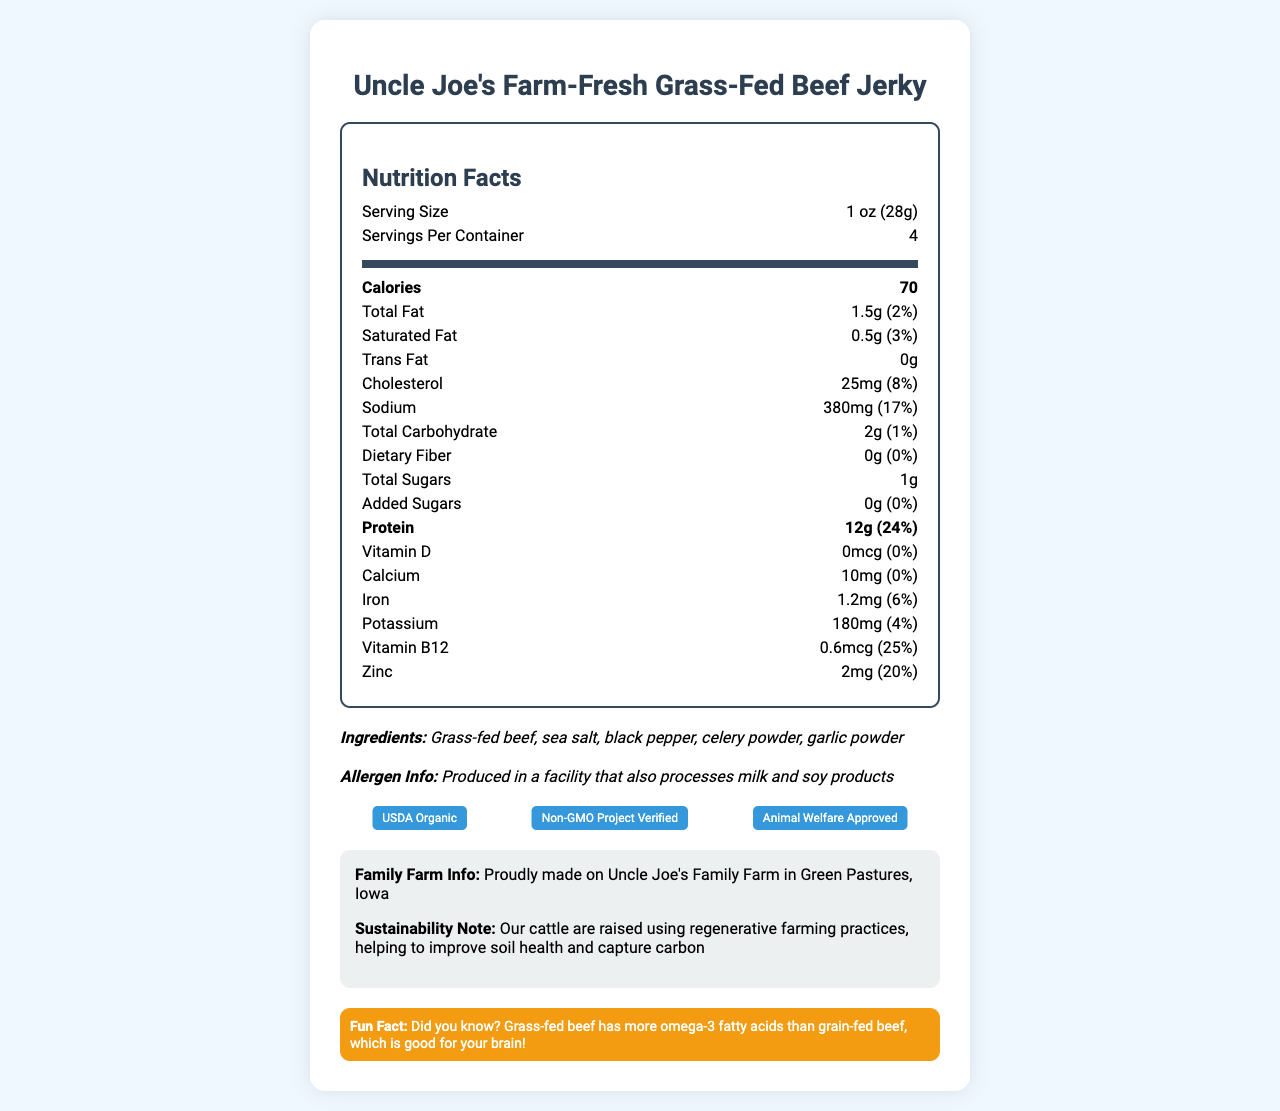what's the serving size for the beef jerky? The serving size is displayed at the top of the nutrition facts section.
Answer: 1 oz (28g) how many calories are there per serving? The document indicates that each serving contains 70 calories.
Answer: 70 how much protein does one serving of beef jerky contain? The protein amount is provided under the nutrition facts and states 12g of protein per serving.
Answer: 12g what is the total fat content per serving, and what percentage of the daily value does it represent? The total fat content per serving is listed as 1.5g, which represents 2% of the daily value.
Answer: 1.5g, 2% how much sodium is in each serving of the beef jerky? The sodium content per serving is listed as 380mg in the nutrition facts.
Answer: 380mg which vitamins and minerals are present in the beef jerky, and what are their daily values? The nutrition facts list the specific vitamins and minerals along with their percentages of the daily value.
Answer: Vitamin D (0%), Calcium (0%), Iron (6%), Potassium (4%), Vitamin B12 (25%), Zinc (20%) are there any added sugars in the beef jerky? The document states that there are 0g of added sugars in the beef jerky.
Answer: No what are the main ingredients listed for Uncle Joe's Farm-Fresh Grass-Fed Beef Jerky? The ingredients list these items in italics under the ingredient section.
Answer: Grass-fed beef, sea salt, black pepper, celery powder, garlic powder what certifications does this product have? A. USDA Organic B. Non-GMO Project Verified C. Gluten-Free D. Animal Welfare Approved The document mentions three certifications: USDA Organic, Non-GMO Project Verified, and Animal Welfare Approved.
Answer: A, B, D how much iron is in one serving of this beef jerky? The nutrition facts section lists the iron content as 1.2mg per serving.
Answer: 1.2mg based on the nutrition facts, is this beef jerky considered a high-protein snack? With 12g of protein per serving, which is 24% of the daily value, the beef jerky is considered a high-protein snack.
Answer: Yes is this beef jerky suitable for people with soy allergies? The allergen information states that the product is produced in a facility that also processes soy products.
Answer: No what is the fun fact mentioned in the kid-friendly section? This fact is highlighted in the kid-friendly fact section at the bottom of the document.
Answer: Grass-fed beef has more omega-3 fatty acids than grain-fed beef, which is good for your brain! how many servings are there in one container of Uncle Joe's Farm-Fresh Grass-Fed Beef Jerky? The document states that there are 4 servings per container.
Answer: 4 describe the main idea of the document. The document lays out detailed information about the beef jerky, including its nutritional content, ingredient list, allergen information, certifications, and specific details about the family farm and sustainability practices.
Answer: The document provides nutritional information, ingredients, allergen warnings, certifications, and general details about Uncle Joe's Farm-Fresh Grass-Fed Beef Jerky, highlighting its high protein content and low-fat content while emphasizing its production on a family farm using sustainable practices. where is Uncle Joe's Family Farm located? The family farm information section mentions that the farm is located in Green Pastures, Iowa.
Answer: Green Pastures, Iowa how much vitamin D is present in the beef jerky? A. 0mcg B. 0.6mcg C. 1mg D. 2mg The nutrition facts indicate that there is 0mcg of vitamin D in the beef jerky.
Answer: A does the beef jerky contain any trans fat? The trans fat content is listed as 0g in the nutrition facts.
Answer: No can you determine the amount of omega-3 fatty acids in the beef jerky based on the information provided? The document mentions that grass-fed beef has more omega-3 fatty acids than grain-fed beef, but it does not specify the amount.
Answer: Not enough information 